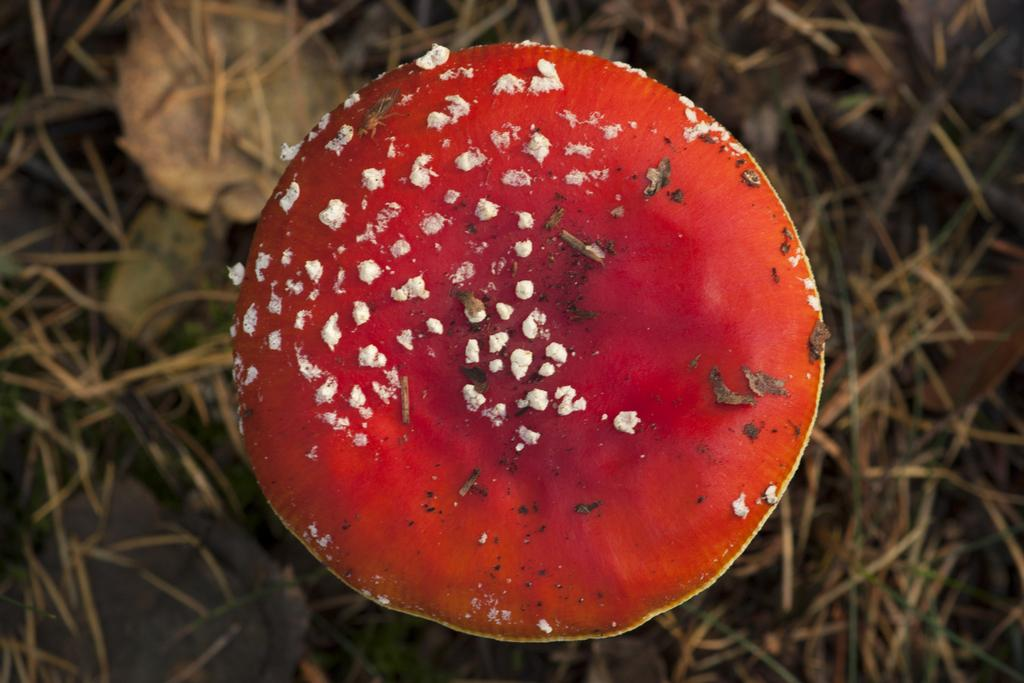What type of mushroom is present in the image? There is a red mushroom in the image. What type of vegetation can be seen in the image? There is dried grass in the image. What type of coat is the mushroom wearing in the image? There is no coat present in the image, as mushrooms do not wear clothing. 